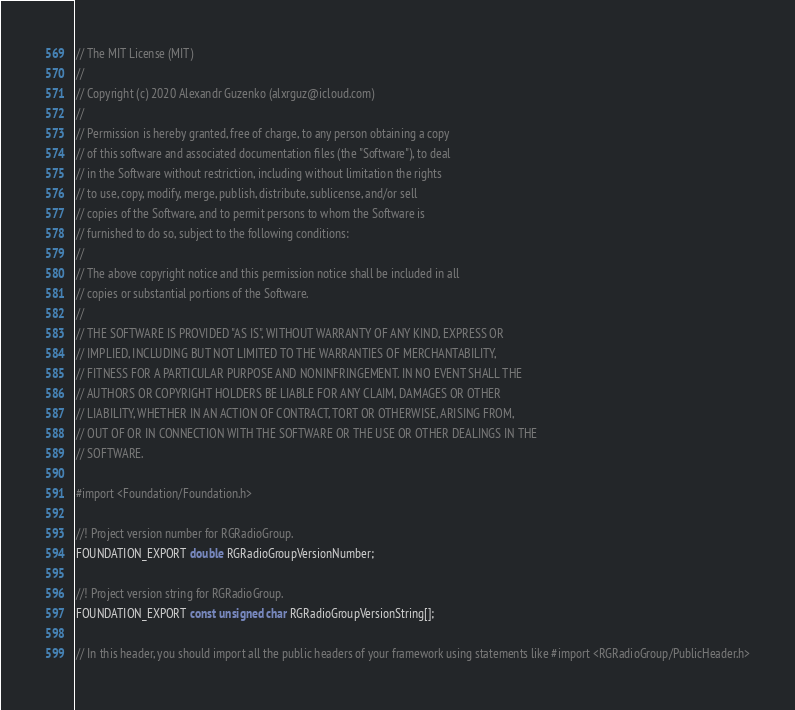<code> <loc_0><loc_0><loc_500><loc_500><_C_>// The MIT License (MIT)
//
// Copyright (c) 2020 Alexandr Guzenko (alxrguz@icloud.com)
//
// Permission is hereby granted, free of charge, to any person obtaining a copy
// of this software and associated documentation files (the "Software"), to deal
// in the Software without restriction, including without limitation the rights
// to use, copy, modify, merge, publish, distribute, sublicense, and/or sell
// copies of the Software, and to permit persons to whom the Software is
// furnished to do so, subject to the following conditions:
//
// The above copyright notice and this permission notice shall be included in all
// copies or substantial portions of the Software.
//
// THE SOFTWARE IS PROVIDED "AS IS", WITHOUT WARRANTY OF ANY KIND, EXPRESS OR
// IMPLIED, INCLUDING BUT NOT LIMITED TO THE WARRANTIES OF MERCHANTABILITY,
// FITNESS FOR A PARTICULAR PURPOSE AND NONINFRINGEMENT. IN NO EVENT SHALL THE
// AUTHORS OR COPYRIGHT HOLDERS BE LIABLE FOR ANY CLAIM, DAMAGES OR OTHER
// LIABILITY, WHETHER IN AN ACTION OF CONTRACT, TORT OR OTHERWISE, ARISING FROM,
// OUT OF OR IN CONNECTION WITH THE SOFTWARE OR THE USE OR OTHER DEALINGS IN THE
// SOFTWARE.

#import <Foundation/Foundation.h>

//! Project version number for RGRadioGroup.
FOUNDATION_EXPORT double RGRadioGroupVersionNumber;

//! Project version string for RGRadioGroup.
FOUNDATION_EXPORT const unsigned char RGRadioGroupVersionString[];

// In this header, you should import all the public headers of your framework using statements like #import <RGRadioGroup/PublicHeader.h>


</code> 